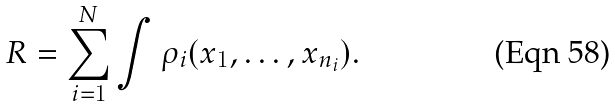<formula> <loc_0><loc_0><loc_500><loc_500>R = \sum _ { i = 1 } ^ { N } \int \rho _ { i } ( x _ { 1 } , \dots , x _ { n _ { i } } ) .</formula> 